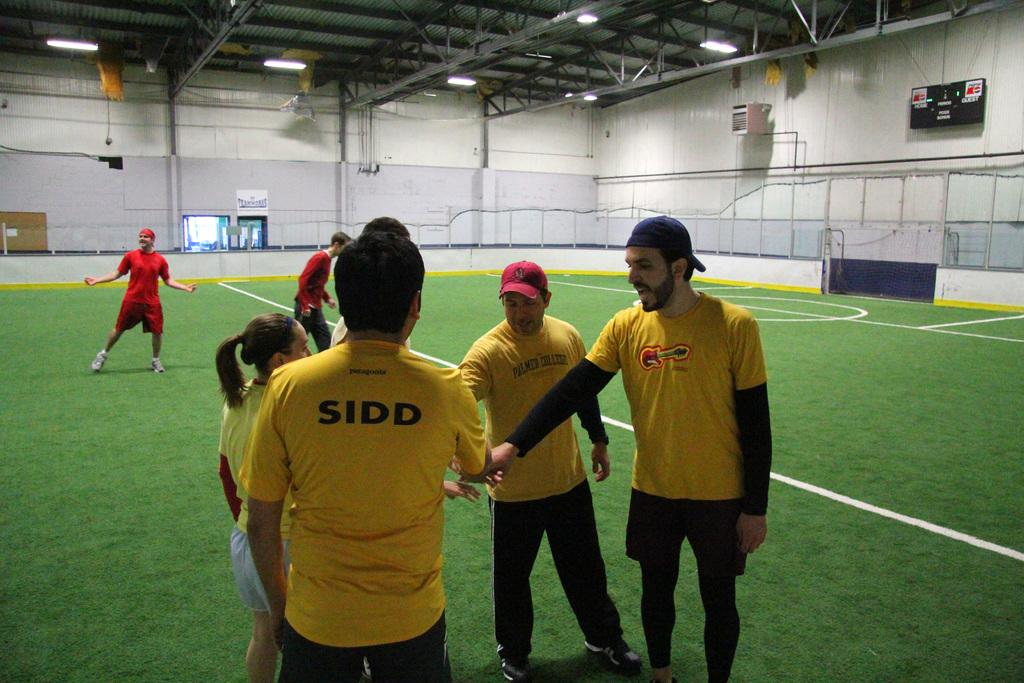<image>
Provide a brief description of the given image. A person with SIDD on the back of his or her shirt put a hand out to the other people. 